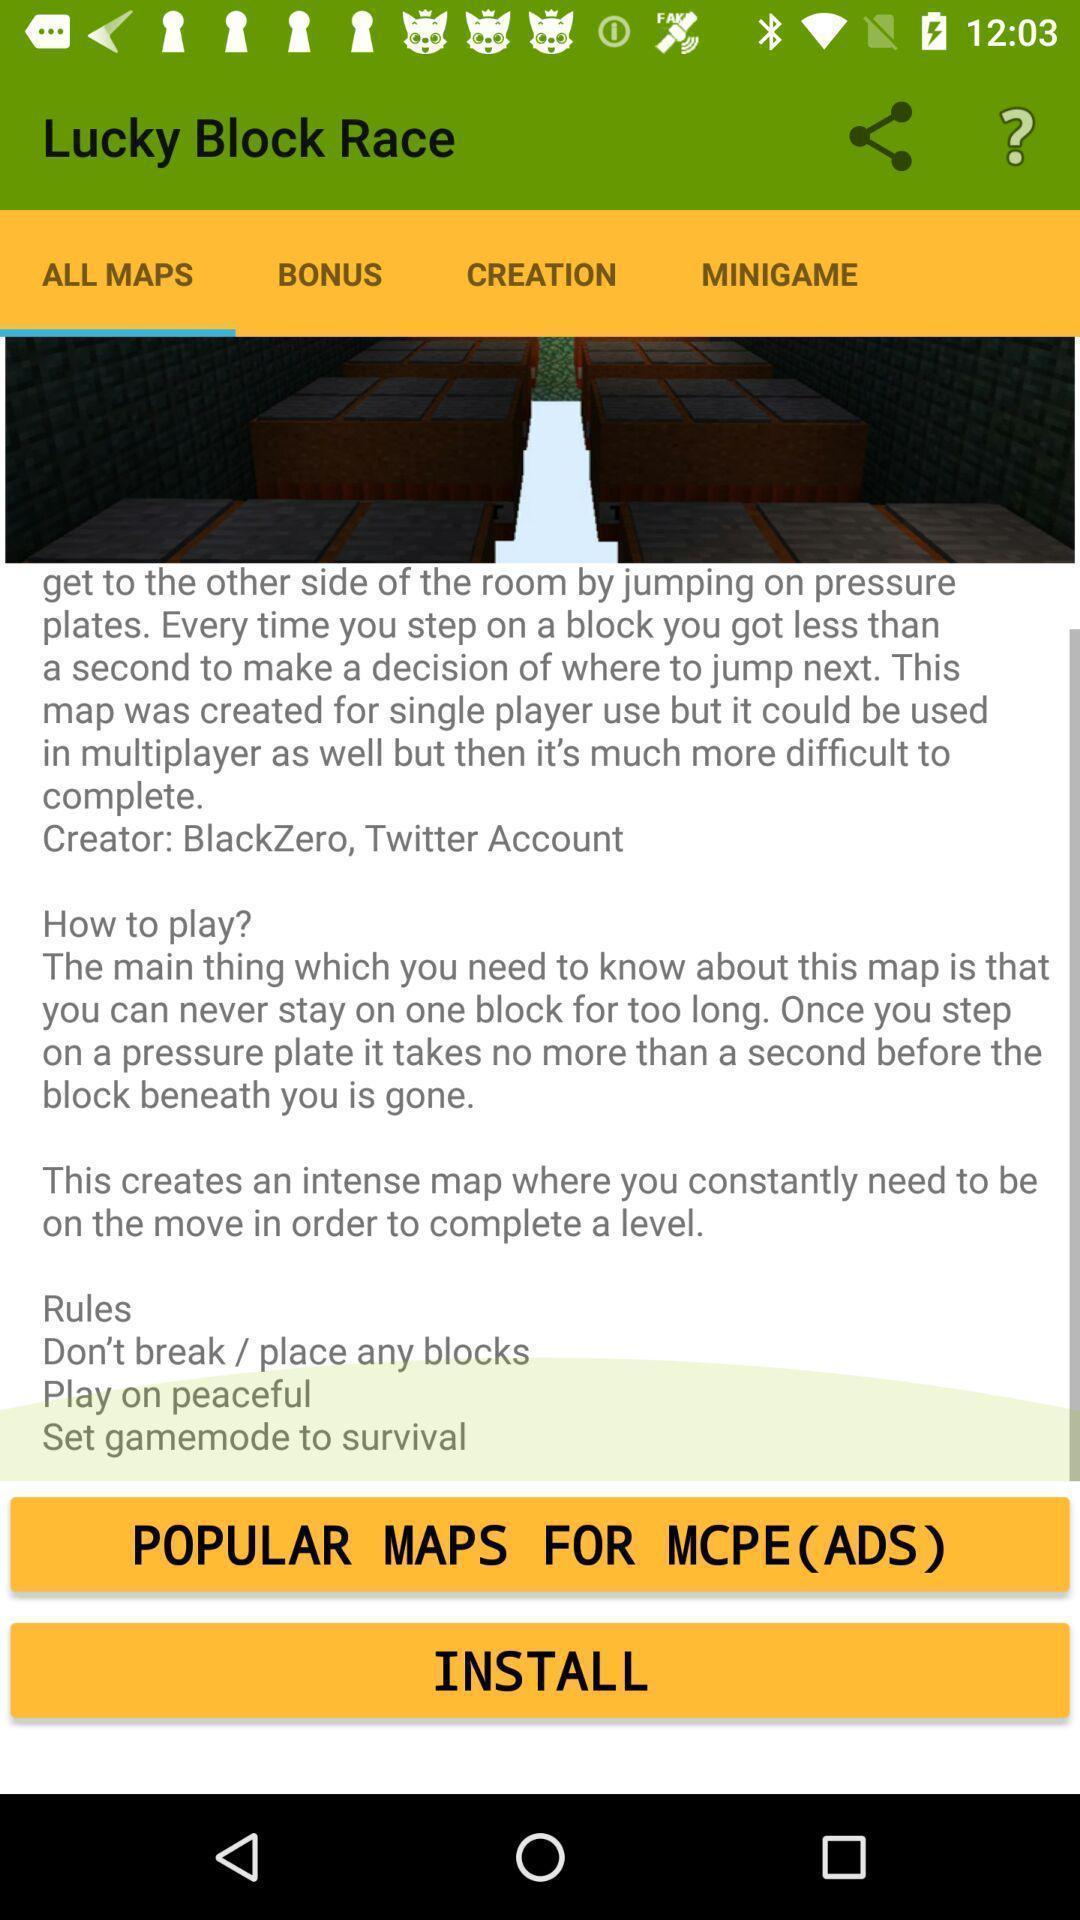Summarize the main components in this picture. Screen displaying all maps page. 